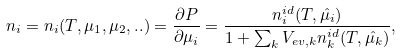<formula> <loc_0><loc_0><loc_500><loc_500>n _ { i } = n _ { i } ( T , \mu _ { 1 } , \mu _ { 2 } , . . ) & = \frac { \partial P } { \partial \mu _ { i } } = \frac { n _ { i } ^ { i d } ( T , \hat { \mu _ { i } } ) } { 1 + \sum _ { k } V _ { e v , k } n _ { k } ^ { i d } ( T , \hat { \mu _ { k } } ) } ,</formula> 